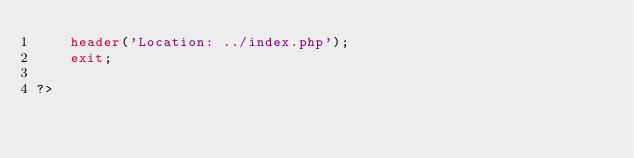Convert code to text. <code><loc_0><loc_0><loc_500><loc_500><_PHP_>    header('Location: ../index.php');
    exit;
   
?></code> 